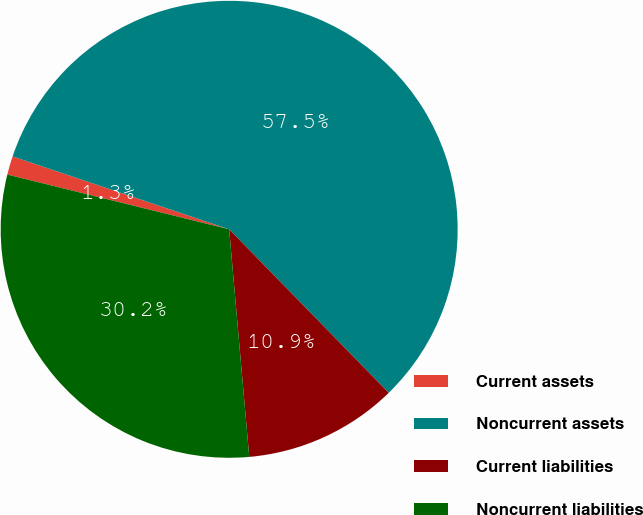Convert chart to OTSL. <chart><loc_0><loc_0><loc_500><loc_500><pie_chart><fcel>Current assets<fcel>Noncurrent assets<fcel>Current liabilities<fcel>Noncurrent liabilities<nl><fcel>1.32%<fcel>57.53%<fcel>10.9%<fcel>30.25%<nl></chart> 